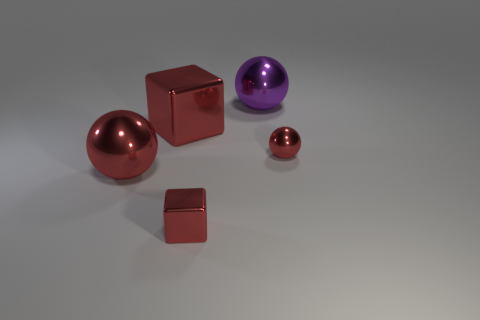How does the lighting in this scene affect the appearance of the metallic surfaces? The lighting in the scene creates soft reflections and highlights on the metallic surfaces, emphasizing their polished texture and contributing to the depth and realism of the objects. 